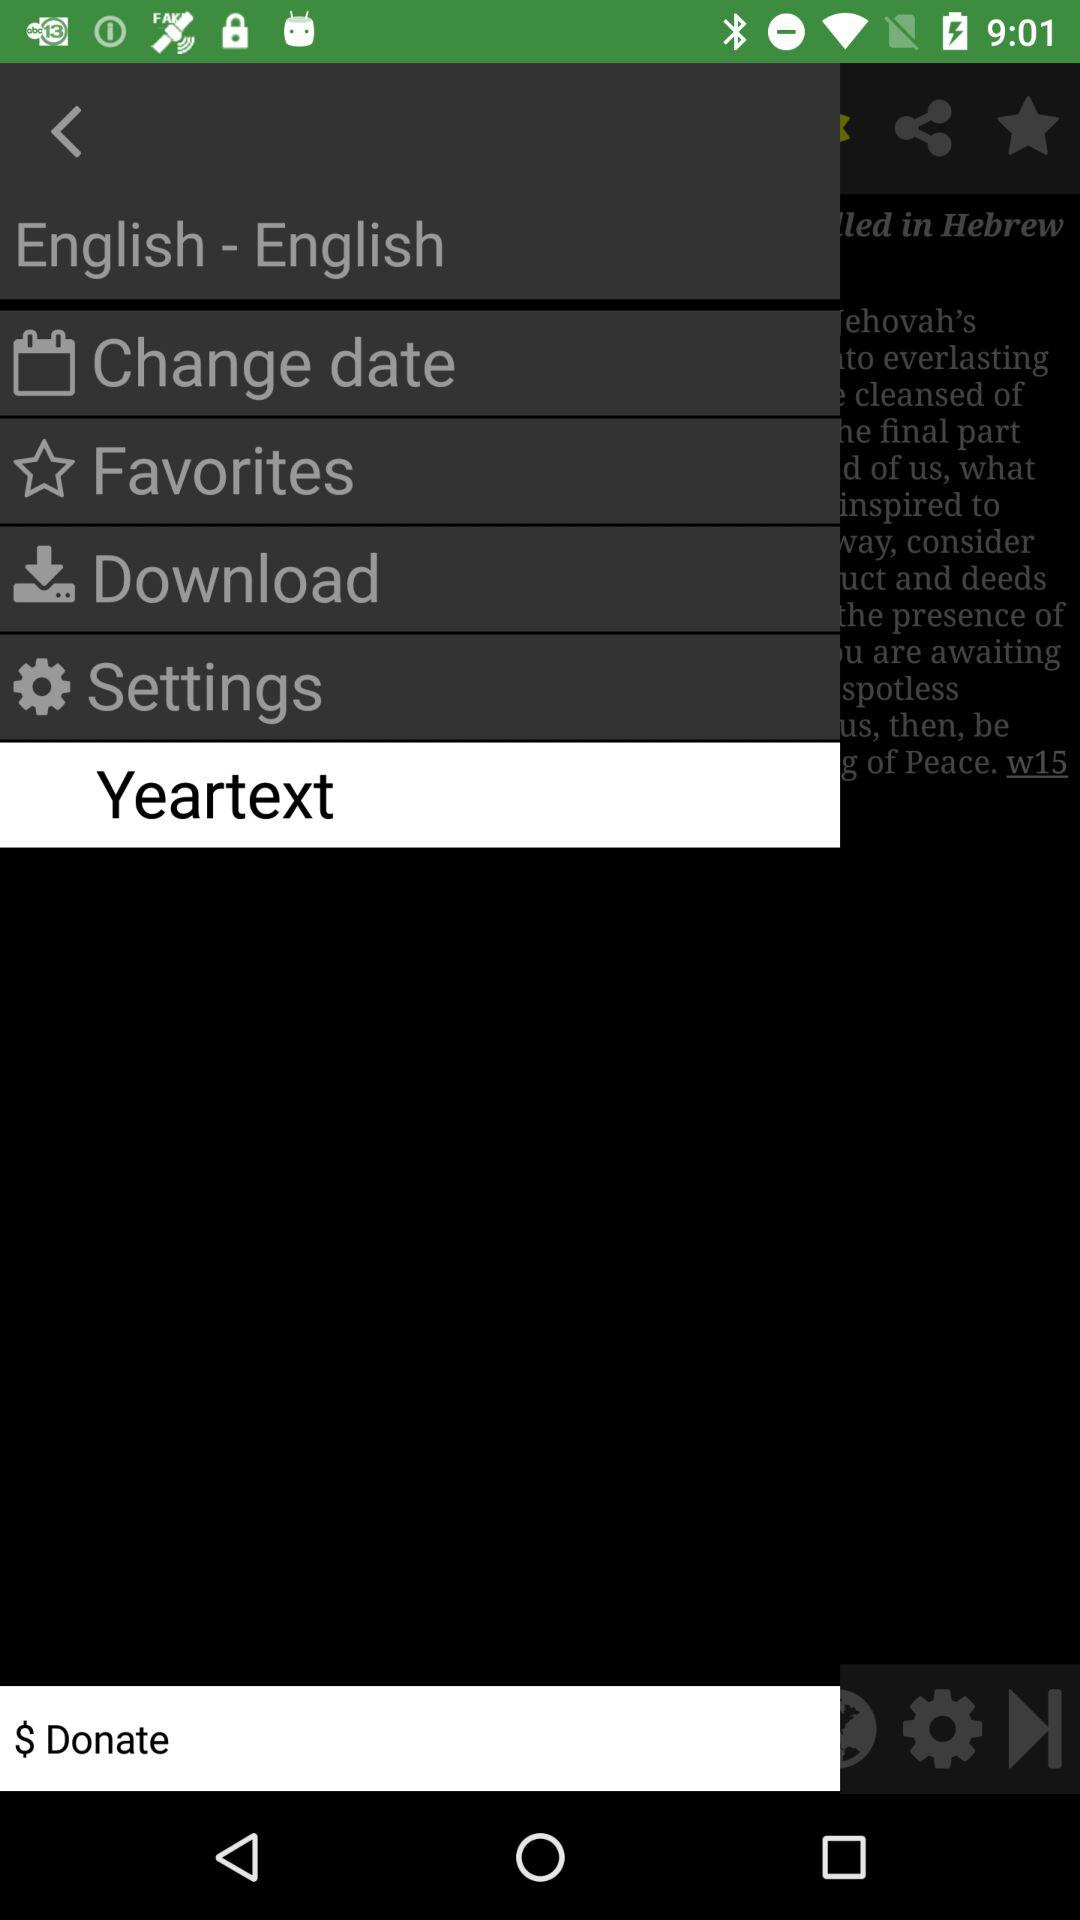Which item is selected in the menu? The selected item is "Yeartext". 